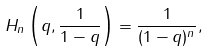<formula> <loc_0><loc_0><loc_500><loc_500>H _ { n } \left ( q , \frac { 1 } { 1 - q } \right ) = \frac { 1 } { ( 1 - q ) ^ { n } } ,</formula> 